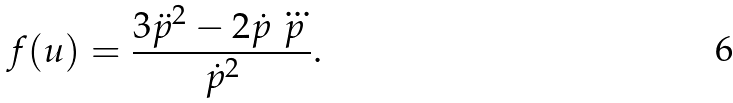Convert formula to latex. <formula><loc_0><loc_0><loc_500><loc_500>f ( u ) = \frac { 3 \ddot { p } ^ { 2 } - 2 \dot { p } \, \dddot { p } } { \dot { p } ^ { 2 } } .</formula> 